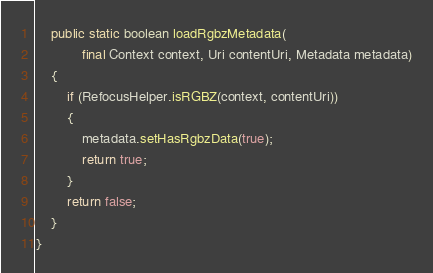Convert code to text. <code><loc_0><loc_0><loc_500><loc_500><_Java_>    public static boolean loadRgbzMetadata(
            final Context context, Uri contentUri, Metadata metadata)
    {
        if (RefocusHelper.isRGBZ(context, contentUri))
        {
            metadata.setHasRgbzData(true);
            return true;
        }
        return false;
    }
}
</code> 